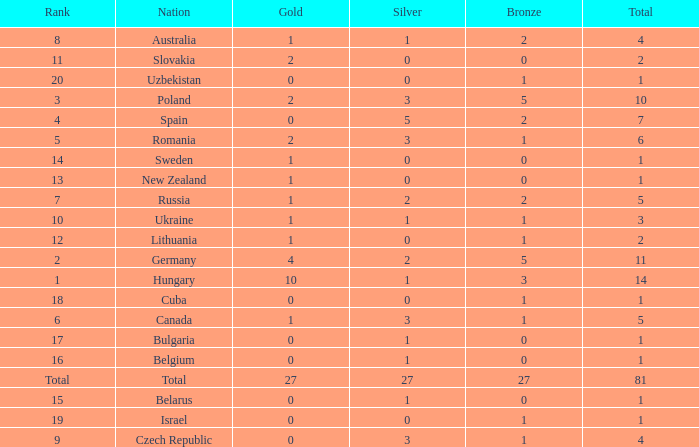Which Bronze has a Gold of 2, and a Nation of slovakia, and a Total larger than 2? None. 